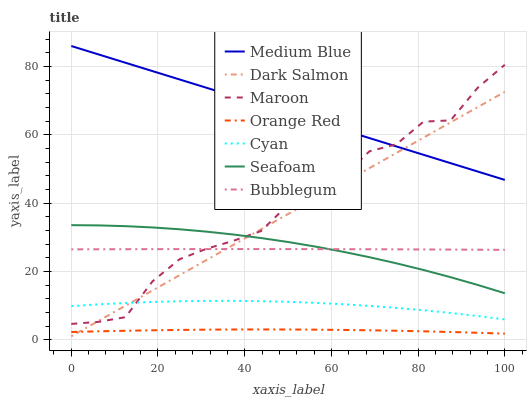Does Orange Red have the minimum area under the curve?
Answer yes or no. Yes. Does Medium Blue have the maximum area under the curve?
Answer yes or no. Yes. Does Seafoam have the minimum area under the curve?
Answer yes or no. No. Does Seafoam have the maximum area under the curve?
Answer yes or no. No. Is Dark Salmon the smoothest?
Answer yes or no. Yes. Is Maroon the roughest?
Answer yes or no. Yes. Is Seafoam the smoothest?
Answer yes or no. No. Is Seafoam the roughest?
Answer yes or no. No. Does Dark Salmon have the lowest value?
Answer yes or no. Yes. Does Seafoam have the lowest value?
Answer yes or no. No. Does Medium Blue have the highest value?
Answer yes or no. Yes. Does Seafoam have the highest value?
Answer yes or no. No. Is Orange Red less than Seafoam?
Answer yes or no. Yes. Is Maroon greater than Orange Red?
Answer yes or no. Yes. Does Cyan intersect Dark Salmon?
Answer yes or no. Yes. Is Cyan less than Dark Salmon?
Answer yes or no. No. Is Cyan greater than Dark Salmon?
Answer yes or no. No. Does Orange Red intersect Seafoam?
Answer yes or no. No. 